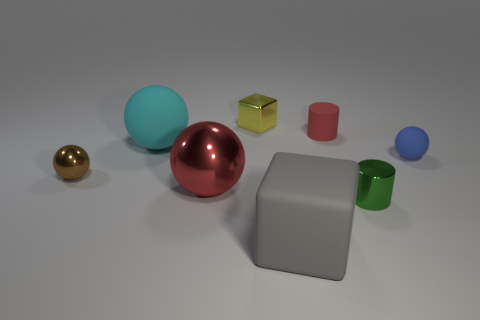The tiny thing that is to the left of the cyan rubber sphere is what color?
Your answer should be very brief. Brown. Are there an equal number of blue things that are in front of the blue matte ball and tiny gray cylinders?
Make the answer very short. Yes. What shape is the object that is in front of the tiny brown sphere and to the right of the small red cylinder?
Make the answer very short. Cylinder. What is the color of the other rubber thing that is the same shape as the cyan rubber thing?
Your answer should be compact. Blue. Is there anything else that is the same color as the large metallic object?
Offer a terse response. Yes. What is the shape of the large rubber object right of the large ball behind the shiny ball that is to the right of the big rubber sphere?
Make the answer very short. Cube. Is the size of the cube that is behind the gray matte cube the same as the shiny sphere to the right of the cyan matte sphere?
Ensure brevity in your answer.  No. What number of small green things are made of the same material as the yellow block?
Your answer should be very brief. 1. How many red matte objects are behind the tiny rubber thing right of the red thing to the right of the big gray object?
Keep it short and to the point. 1. Does the brown shiny thing have the same shape as the tiny yellow metal object?
Keep it short and to the point. No. 